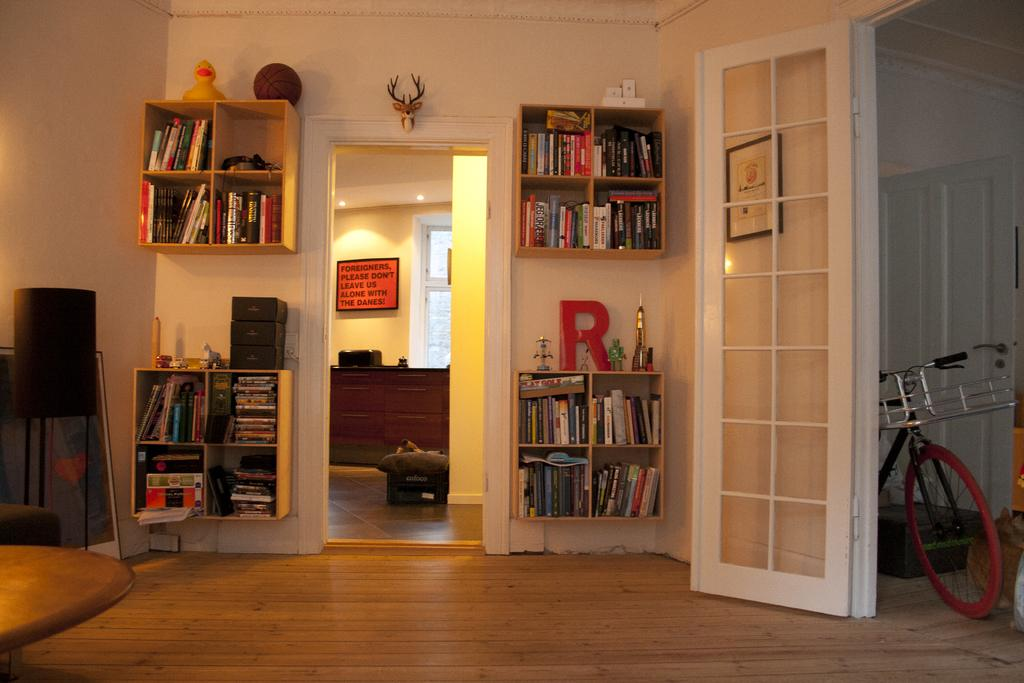<image>
Relay a brief, clear account of the picture shown. a bookcase in a house with the letter R above it 